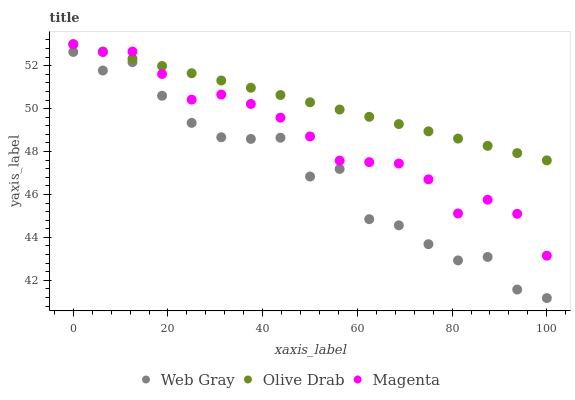Does Web Gray have the minimum area under the curve?
Answer yes or no. Yes. Does Olive Drab have the maximum area under the curve?
Answer yes or no. Yes. Does Olive Drab have the minimum area under the curve?
Answer yes or no. No. Does Web Gray have the maximum area under the curve?
Answer yes or no. No. Is Olive Drab the smoothest?
Answer yes or no. Yes. Is Web Gray the roughest?
Answer yes or no. Yes. Is Web Gray the smoothest?
Answer yes or no. No. Is Olive Drab the roughest?
Answer yes or no. No. Does Web Gray have the lowest value?
Answer yes or no. Yes. Does Olive Drab have the lowest value?
Answer yes or no. No. Does Olive Drab have the highest value?
Answer yes or no. Yes. Does Web Gray have the highest value?
Answer yes or no. No. Is Web Gray less than Magenta?
Answer yes or no. Yes. Is Magenta greater than Web Gray?
Answer yes or no. Yes. Does Olive Drab intersect Magenta?
Answer yes or no. Yes. Is Olive Drab less than Magenta?
Answer yes or no. No. Is Olive Drab greater than Magenta?
Answer yes or no. No. Does Web Gray intersect Magenta?
Answer yes or no. No. 